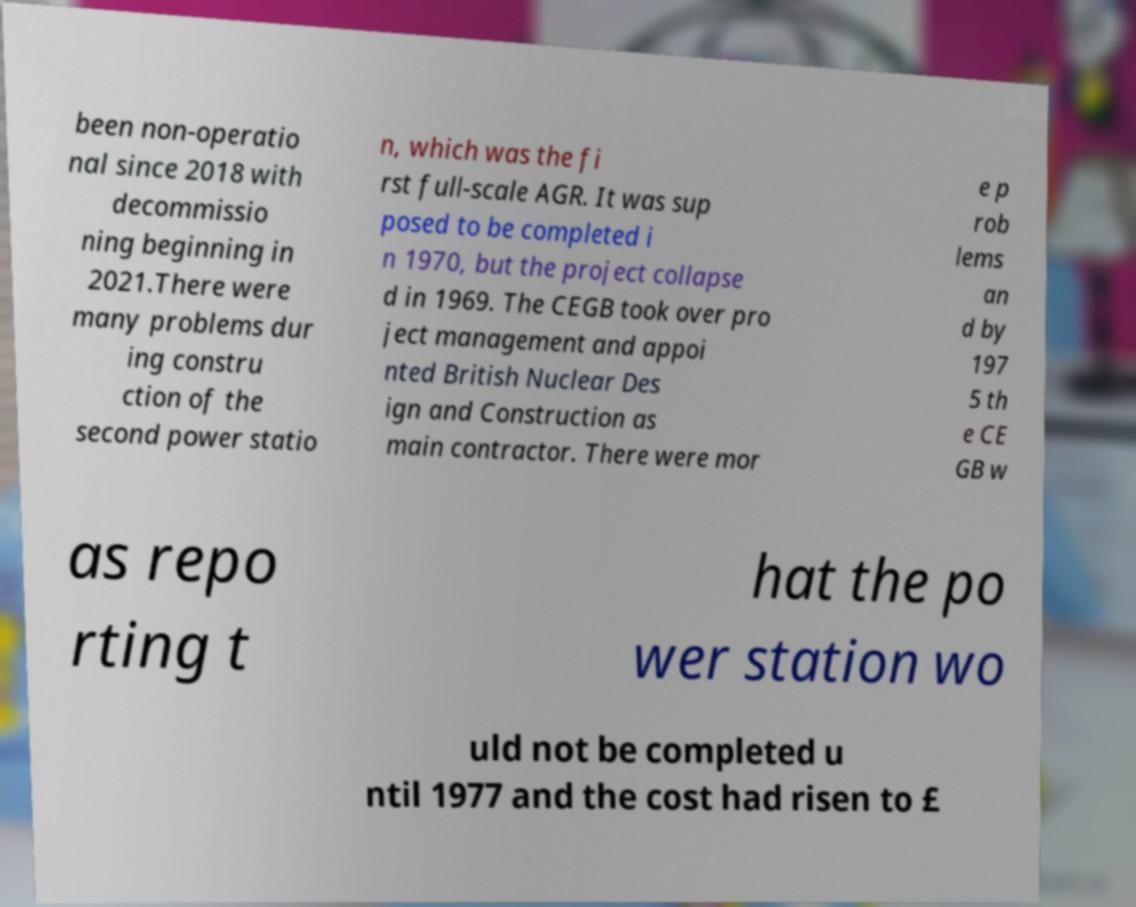There's text embedded in this image that I need extracted. Can you transcribe it verbatim? been non-operatio nal since 2018 with decommissio ning beginning in 2021.There were many problems dur ing constru ction of the second power statio n, which was the fi rst full-scale AGR. It was sup posed to be completed i n 1970, but the project collapse d in 1969. The CEGB took over pro ject management and appoi nted British Nuclear Des ign and Construction as main contractor. There were mor e p rob lems an d by 197 5 th e CE GB w as repo rting t hat the po wer station wo uld not be completed u ntil 1977 and the cost had risen to £ 